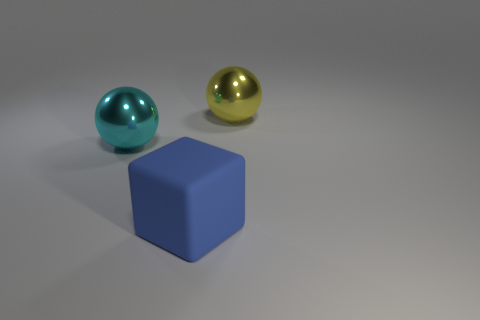Given their colors, how do these objects relate to each other in the image? The objects' colors - cyan, gold, and blue - provide a complementary palette that is aesthetically pleasing. The blue cube stands out as the central anchor of the composition, while the cyan and gold spheres add visual interest through their placement and the contrast in hues. 